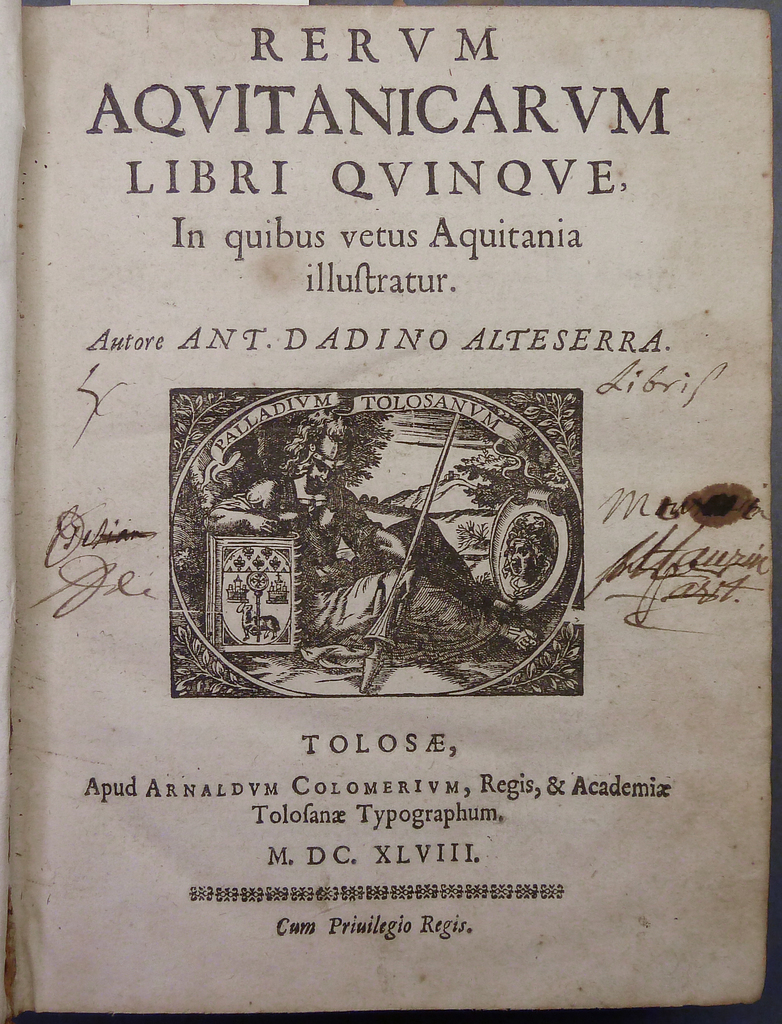What historical information can be surmised from the text and images on this ancient book's title page? The title indicates that the book is about the 'things of Aquitaine' and was written to illustrate the history of ancient Aquitaine. The ornate artwork, featuring a shield and a figure, possibly suggests a focus on noble lineages or significant historical figures and events of the region. The presence of the 'Privilegio Regis' seal also points to the book having royal approval or patronage. 